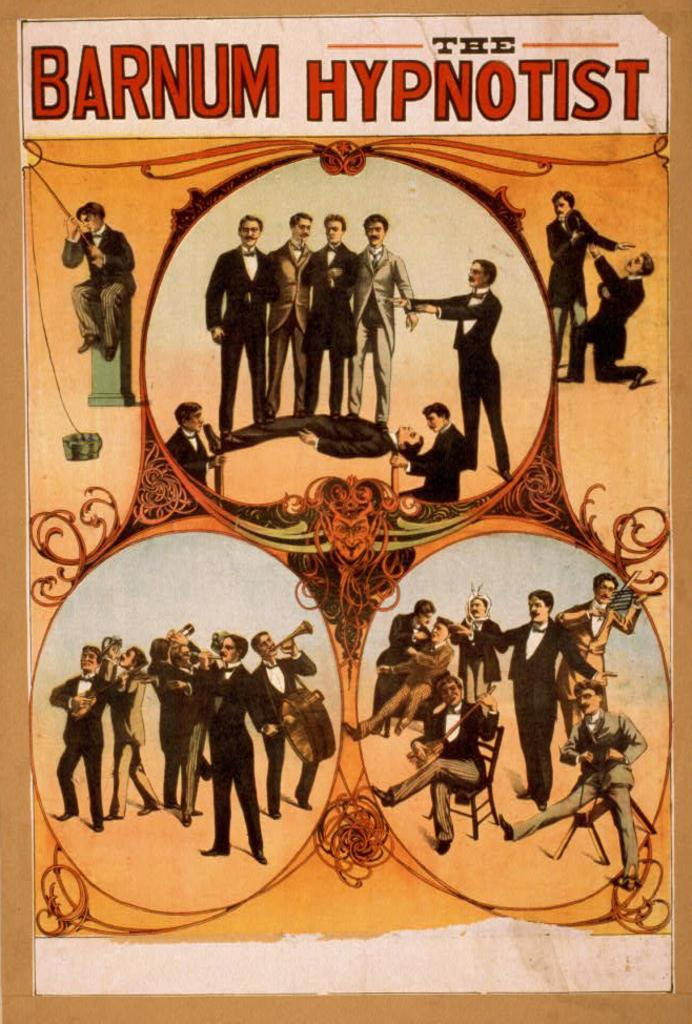<image>
Summarize the visual content of the image. A vintage poster is the title "the Barnum hypnotist" 